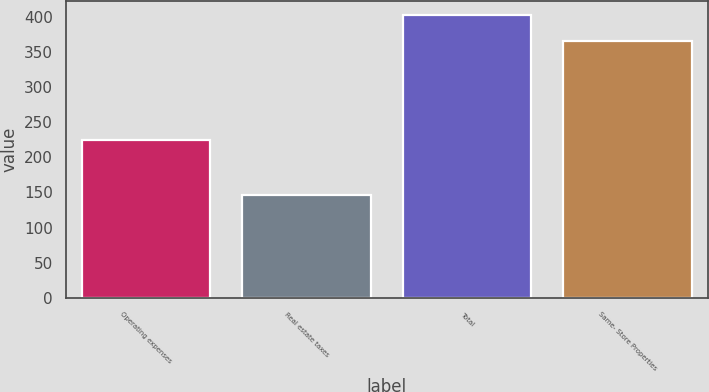Convert chart. <chart><loc_0><loc_0><loc_500><loc_500><bar_chart><fcel>Operating expenses<fcel>Real estate taxes<fcel>Total<fcel>Same- Store Properties<nl><fcel>224.7<fcel>145.8<fcel>401.7<fcel>365<nl></chart> 